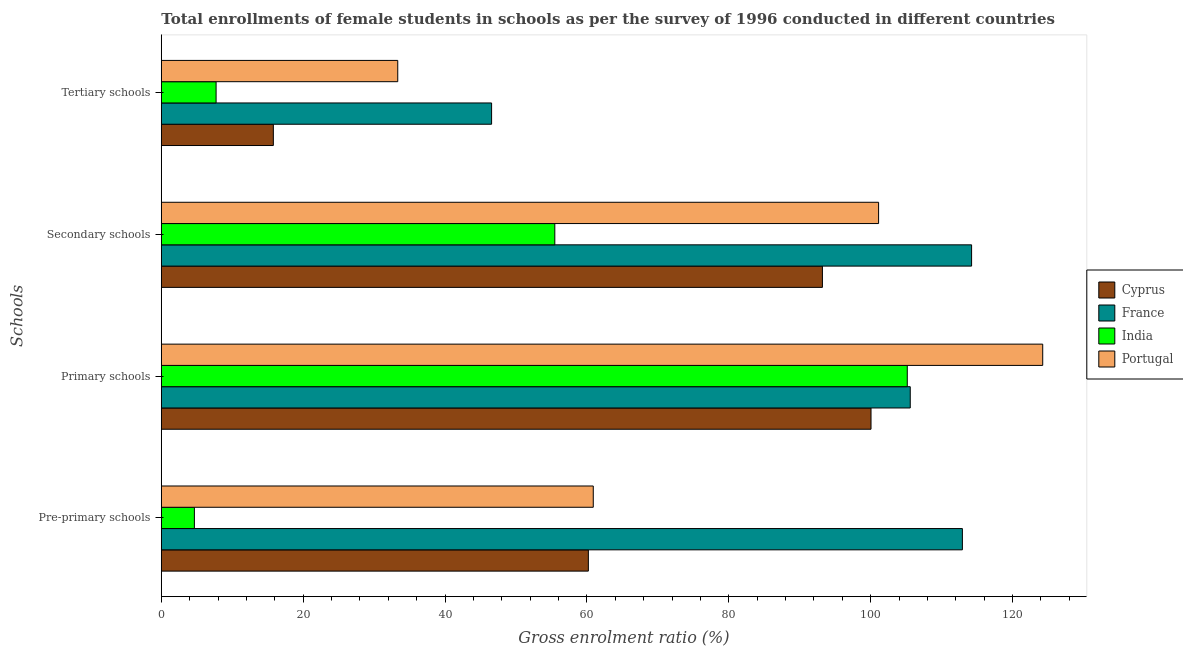How many different coloured bars are there?
Make the answer very short. 4. How many groups of bars are there?
Your answer should be very brief. 4. Are the number of bars on each tick of the Y-axis equal?
Keep it short and to the point. Yes. What is the label of the 1st group of bars from the top?
Offer a terse response. Tertiary schools. What is the gross enrolment ratio(female) in primary schools in Cyprus?
Provide a succinct answer. 100.05. Across all countries, what is the maximum gross enrolment ratio(female) in secondary schools?
Make the answer very short. 114.23. Across all countries, what is the minimum gross enrolment ratio(female) in tertiary schools?
Give a very brief answer. 7.72. What is the total gross enrolment ratio(female) in tertiary schools in the graph?
Your answer should be compact. 103.41. What is the difference between the gross enrolment ratio(female) in pre-primary schools in Cyprus and that in France?
Offer a very short reply. -52.73. What is the difference between the gross enrolment ratio(female) in tertiary schools in Cyprus and the gross enrolment ratio(female) in pre-primary schools in Portugal?
Make the answer very short. -45.1. What is the average gross enrolment ratio(female) in primary schools per country?
Your answer should be compact. 108.76. What is the difference between the gross enrolment ratio(female) in primary schools and gross enrolment ratio(female) in secondary schools in Cyprus?
Your answer should be very brief. 6.85. In how many countries, is the gross enrolment ratio(female) in pre-primary schools greater than 64 %?
Ensure brevity in your answer.  1. What is the ratio of the gross enrolment ratio(female) in pre-primary schools in France to that in India?
Provide a succinct answer. 24.22. What is the difference between the highest and the second highest gross enrolment ratio(female) in tertiary schools?
Ensure brevity in your answer.  13.23. What is the difference between the highest and the lowest gross enrolment ratio(female) in secondary schools?
Give a very brief answer. 58.76. In how many countries, is the gross enrolment ratio(female) in secondary schools greater than the average gross enrolment ratio(female) in secondary schools taken over all countries?
Make the answer very short. 3. Is the sum of the gross enrolment ratio(female) in tertiary schools in Portugal and India greater than the maximum gross enrolment ratio(female) in secondary schools across all countries?
Your response must be concise. No. Is it the case that in every country, the sum of the gross enrolment ratio(female) in primary schools and gross enrolment ratio(female) in secondary schools is greater than the sum of gross enrolment ratio(female) in pre-primary schools and gross enrolment ratio(female) in tertiary schools?
Provide a succinct answer. Yes. What does the 3rd bar from the top in Tertiary schools represents?
Ensure brevity in your answer.  France. What does the 4th bar from the bottom in Tertiary schools represents?
Make the answer very short. Portugal. How many bars are there?
Your answer should be compact. 16. How many countries are there in the graph?
Your response must be concise. 4. What is the difference between two consecutive major ticks on the X-axis?
Offer a terse response. 20. How many legend labels are there?
Your answer should be very brief. 4. What is the title of the graph?
Provide a short and direct response. Total enrollments of female students in schools as per the survey of 1996 conducted in different countries. What is the label or title of the X-axis?
Offer a terse response. Gross enrolment ratio (%). What is the label or title of the Y-axis?
Ensure brevity in your answer.  Schools. What is the Gross enrolment ratio (%) of Cyprus in Pre-primary schools?
Ensure brevity in your answer.  60.2. What is the Gross enrolment ratio (%) of France in Pre-primary schools?
Provide a succinct answer. 112.93. What is the Gross enrolment ratio (%) in India in Pre-primary schools?
Make the answer very short. 4.66. What is the Gross enrolment ratio (%) in Portugal in Pre-primary schools?
Your answer should be compact. 60.9. What is the Gross enrolment ratio (%) of Cyprus in Primary schools?
Your response must be concise. 100.05. What is the Gross enrolment ratio (%) of France in Primary schools?
Your response must be concise. 105.58. What is the Gross enrolment ratio (%) of India in Primary schools?
Your answer should be compact. 105.16. What is the Gross enrolment ratio (%) of Portugal in Primary schools?
Your response must be concise. 124.26. What is the Gross enrolment ratio (%) of Cyprus in Secondary schools?
Offer a terse response. 93.2. What is the Gross enrolment ratio (%) in France in Secondary schools?
Ensure brevity in your answer.  114.23. What is the Gross enrolment ratio (%) of India in Secondary schools?
Provide a succinct answer. 55.47. What is the Gross enrolment ratio (%) in Portugal in Secondary schools?
Offer a terse response. 101.12. What is the Gross enrolment ratio (%) of Cyprus in Tertiary schools?
Your response must be concise. 15.79. What is the Gross enrolment ratio (%) in France in Tertiary schools?
Ensure brevity in your answer.  46.56. What is the Gross enrolment ratio (%) of India in Tertiary schools?
Make the answer very short. 7.72. What is the Gross enrolment ratio (%) in Portugal in Tertiary schools?
Ensure brevity in your answer.  33.33. Across all Schools, what is the maximum Gross enrolment ratio (%) of Cyprus?
Provide a succinct answer. 100.05. Across all Schools, what is the maximum Gross enrolment ratio (%) of France?
Your answer should be compact. 114.23. Across all Schools, what is the maximum Gross enrolment ratio (%) in India?
Your response must be concise. 105.16. Across all Schools, what is the maximum Gross enrolment ratio (%) in Portugal?
Keep it short and to the point. 124.26. Across all Schools, what is the minimum Gross enrolment ratio (%) of Cyprus?
Offer a very short reply. 15.79. Across all Schools, what is the minimum Gross enrolment ratio (%) in France?
Provide a succinct answer. 46.56. Across all Schools, what is the minimum Gross enrolment ratio (%) in India?
Make the answer very short. 4.66. Across all Schools, what is the minimum Gross enrolment ratio (%) in Portugal?
Provide a short and direct response. 33.33. What is the total Gross enrolment ratio (%) of Cyprus in the graph?
Your answer should be compact. 269.25. What is the total Gross enrolment ratio (%) in France in the graph?
Ensure brevity in your answer.  379.3. What is the total Gross enrolment ratio (%) in India in the graph?
Give a very brief answer. 173.02. What is the total Gross enrolment ratio (%) in Portugal in the graph?
Keep it short and to the point. 319.6. What is the difference between the Gross enrolment ratio (%) of Cyprus in Pre-primary schools and that in Primary schools?
Offer a terse response. -39.85. What is the difference between the Gross enrolment ratio (%) of France in Pre-primary schools and that in Primary schools?
Make the answer very short. 7.35. What is the difference between the Gross enrolment ratio (%) in India in Pre-primary schools and that in Primary schools?
Offer a terse response. -100.5. What is the difference between the Gross enrolment ratio (%) in Portugal in Pre-primary schools and that in Primary schools?
Offer a terse response. -63.36. What is the difference between the Gross enrolment ratio (%) of Cyprus in Pre-primary schools and that in Secondary schools?
Offer a very short reply. -33. What is the difference between the Gross enrolment ratio (%) of France in Pre-primary schools and that in Secondary schools?
Offer a terse response. -1.3. What is the difference between the Gross enrolment ratio (%) in India in Pre-primary schools and that in Secondary schools?
Your answer should be compact. -50.81. What is the difference between the Gross enrolment ratio (%) of Portugal in Pre-primary schools and that in Secondary schools?
Your response must be concise. -40.22. What is the difference between the Gross enrolment ratio (%) in Cyprus in Pre-primary schools and that in Tertiary schools?
Offer a terse response. 44.41. What is the difference between the Gross enrolment ratio (%) of France in Pre-primary schools and that in Tertiary schools?
Your answer should be compact. 66.37. What is the difference between the Gross enrolment ratio (%) of India in Pre-primary schools and that in Tertiary schools?
Give a very brief answer. -3.06. What is the difference between the Gross enrolment ratio (%) in Portugal in Pre-primary schools and that in Tertiary schools?
Provide a short and direct response. 27.56. What is the difference between the Gross enrolment ratio (%) in Cyprus in Primary schools and that in Secondary schools?
Give a very brief answer. 6.85. What is the difference between the Gross enrolment ratio (%) in France in Primary schools and that in Secondary schools?
Your response must be concise. -8.65. What is the difference between the Gross enrolment ratio (%) in India in Primary schools and that in Secondary schools?
Your answer should be compact. 49.69. What is the difference between the Gross enrolment ratio (%) in Portugal in Primary schools and that in Secondary schools?
Offer a very short reply. 23.14. What is the difference between the Gross enrolment ratio (%) of Cyprus in Primary schools and that in Tertiary schools?
Your answer should be compact. 84.26. What is the difference between the Gross enrolment ratio (%) in France in Primary schools and that in Tertiary schools?
Your response must be concise. 59.02. What is the difference between the Gross enrolment ratio (%) of India in Primary schools and that in Tertiary schools?
Provide a succinct answer. 97.44. What is the difference between the Gross enrolment ratio (%) in Portugal in Primary schools and that in Tertiary schools?
Offer a terse response. 90.92. What is the difference between the Gross enrolment ratio (%) in Cyprus in Secondary schools and that in Tertiary schools?
Offer a very short reply. 77.41. What is the difference between the Gross enrolment ratio (%) of France in Secondary schools and that in Tertiary schools?
Provide a succinct answer. 67.67. What is the difference between the Gross enrolment ratio (%) in India in Secondary schools and that in Tertiary schools?
Your answer should be very brief. 47.75. What is the difference between the Gross enrolment ratio (%) in Portugal in Secondary schools and that in Tertiary schools?
Provide a short and direct response. 67.79. What is the difference between the Gross enrolment ratio (%) in Cyprus in Pre-primary schools and the Gross enrolment ratio (%) in France in Primary schools?
Offer a terse response. -45.38. What is the difference between the Gross enrolment ratio (%) in Cyprus in Pre-primary schools and the Gross enrolment ratio (%) in India in Primary schools?
Your answer should be compact. -44.96. What is the difference between the Gross enrolment ratio (%) in Cyprus in Pre-primary schools and the Gross enrolment ratio (%) in Portugal in Primary schools?
Provide a short and direct response. -64.05. What is the difference between the Gross enrolment ratio (%) in France in Pre-primary schools and the Gross enrolment ratio (%) in India in Primary schools?
Make the answer very short. 7.77. What is the difference between the Gross enrolment ratio (%) of France in Pre-primary schools and the Gross enrolment ratio (%) of Portugal in Primary schools?
Your response must be concise. -11.32. What is the difference between the Gross enrolment ratio (%) in India in Pre-primary schools and the Gross enrolment ratio (%) in Portugal in Primary schools?
Your answer should be very brief. -119.59. What is the difference between the Gross enrolment ratio (%) of Cyprus in Pre-primary schools and the Gross enrolment ratio (%) of France in Secondary schools?
Offer a very short reply. -54.03. What is the difference between the Gross enrolment ratio (%) of Cyprus in Pre-primary schools and the Gross enrolment ratio (%) of India in Secondary schools?
Make the answer very short. 4.73. What is the difference between the Gross enrolment ratio (%) in Cyprus in Pre-primary schools and the Gross enrolment ratio (%) in Portugal in Secondary schools?
Give a very brief answer. -40.92. What is the difference between the Gross enrolment ratio (%) in France in Pre-primary schools and the Gross enrolment ratio (%) in India in Secondary schools?
Your answer should be very brief. 57.46. What is the difference between the Gross enrolment ratio (%) in France in Pre-primary schools and the Gross enrolment ratio (%) in Portugal in Secondary schools?
Your response must be concise. 11.81. What is the difference between the Gross enrolment ratio (%) in India in Pre-primary schools and the Gross enrolment ratio (%) in Portugal in Secondary schools?
Make the answer very short. -96.46. What is the difference between the Gross enrolment ratio (%) in Cyprus in Pre-primary schools and the Gross enrolment ratio (%) in France in Tertiary schools?
Ensure brevity in your answer.  13.64. What is the difference between the Gross enrolment ratio (%) in Cyprus in Pre-primary schools and the Gross enrolment ratio (%) in India in Tertiary schools?
Offer a terse response. 52.48. What is the difference between the Gross enrolment ratio (%) of Cyprus in Pre-primary schools and the Gross enrolment ratio (%) of Portugal in Tertiary schools?
Ensure brevity in your answer.  26.87. What is the difference between the Gross enrolment ratio (%) in France in Pre-primary schools and the Gross enrolment ratio (%) in India in Tertiary schools?
Provide a short and direct response. 105.21. What is the difference between the Gross enrolment ratio (%) of France in Pre-primary schools and the Gross enrolment ratio (%) of Portugal in Tertiary schools?
Your response must be concise. 79.6. What is the difference between the Gross enrolment ratio (%) of India in Pre-primary schools and the Gross enrolment ratio (%) of Portugal in Tertiary schools?
Ensure brevity in your answer.  -28.67. What is the difference between the Gross enrolment ratio (%) in Cyprus in Primary schools and the Gross enrolment ratio (%) in France in Secondary schools?
Provide a short and direct response. -14.18. What is the difference between the Gross enrolment ratio (%) in Cyprus in Primary schools and the Gross enrolment ratio (%) in India in Secondary schools?
Offer a terse response. 44.58. What is the difference between the Gross enrolment ratio (%) in Cyprus in Primary schools and the Gross enrolment ratio (%) in Portugal in Secondary schools?
Offer a very short reply. -1.07. What is the difference between the Gross enrolment ratio (%) in France in Primary schools and the Gross enrolment ratio (%) in India in Secondary schools?
Your answer should be very brief. 50.11. What is the difference between the Gross enrolment ratio (%) of France in Primary schools and the Gross enrolment ratio (%) of Portugal in Secondary schools?
Provide a succinct answer. 4.46. What is the difference between the Gross enrolment ratio (%) in India in Primary schools and the Gross enrolment ratio (%) in Portugal in Secondary schools?
Provide a short and direct response. 4.04. What is the difference between the Gross enrolment ratio (%) of Cyprus in Primary schools and the Gross enrolment ratio (%) of France in Tertiary schools?
Provide a succinct answer. 53.49. What is the difference between the Gross enrolment ratio (%) of Cyprus in Primary schools and the Gross enrolment ratio (%) of India in Tertiary schools?
Keep it short and to the point. 92.33. What is the difference between the Gross enrolment ratio (%) of Cyprus in Primary schools and the Gross enrolment ratio (%) of Portugal in Tertiary schools?
Provide a short and direct response. 66.72. What is the difference between the Gross enrolment ratio (%) of France in Primary schools and the Gross enrolment ratio (%) of India in Tertiary schools?
Your answer should be compact. 97.86. What is the difference between the Gross enrolment ratio (%) of France in Primary schools and the Gross enrolment ratio (%) of Portugal in Tertiary schools?
Offer a very short reply. 72.25. What is the difference between the Gross enrolment ratio (%) of India in Primary schools and the Gross enrolment ratio (%) of Portugal in Tertiary schools?
Offer a very short reply. 71.83. What is the difference between the Gross enrolment ratio (%) of Cyprus in Secondary schools and the Gross enrolment ratio (%) of France in Tertiary schools?
Provide a succinct answer. 46.64. What is the difference between the Gross enrolment ratio (%) of Cyprus in Secondary schools and the Gross enrolment ratio (%) of India in Tertiary schools?
Make the answer very short. 85.48. What is the difference between the Gross enrolment ratio (%) in Cyprus in Secondary schools and the Gross enrolment ratio (%) in Portugal in Tertiary schools?
Keep it short and to the point. 59.87. What is the difference between the Gross enrolment ratio (%) in France in Secondary schools and the Gross enrolment ratio (%) in India in Tertiary schools?
Provide a short and direct response. 106.51. What is the difference between the Gross enrolment ratio (%) of France in Secondary schools and the Gross enrolment ratio (%) of Portugal in Tertiary schools?
Your answer should be compact. 80.9. What is the difference between the Gross enrolment ratio (%) in India in Secondary schools and the Gross enrolment ratio (%) in Portugal in Tertiary schools?
Provide a succinct answer. 22.14. What is the average Gross enrolment ratio (%) of Cyprus per Schools?
Your answer should be compact. 67.31. What is the average Gross enrolment ratio (%) in France per Schools?
Offer a very short reply. 94.83. What is the average Gross enrolment ratio (%) in India per Schools?
Provide a short and direct response. 43.26. What is the average Gross enrolment ratio (%) of Portugal per Schools?
Offer a very short reply. 79.9. What is the difference between the Gross enrolment ratio (%) of Cyprus and Gross enrolment ratio (%) of France in Pre-primary schools?
Your answer should be very brief. -52.73. What is the difference between the Gross enrolment ratio (%) in Cyprus and Gross enrolment ratio (%) in India in Pre-primary schools?
Make the answer very short. 55.54. What is the difference between the Gross enrolment ratio (%) of Cyprus and Gross enrolment ratio (%) of Portugal in Pre-primary schools?
Your answer should be very brief. -0.69. What is the difference between the Gross enrolment ratio (%) of France and Gross enrolment ratio (%) of India in Pre-primary schools?
Ensure brevity in your answer.  108.27. What is the difference between the Gross enrolment ratio (%) of France and Gross enrolment ratio (%) of Portugal in Pre-primary schools?
Ensure brevity in your answer.  52.04. What is the difference between the Gross enrolment ratio (%) of India and Gross enrolment ratio (%) of Portugal in Pre-primary schools?
Provide a short and direct response. -56.23. What is the difference between the Gross enrolment ratio (%) of Cyprus and Gross enrolment ratio (%) of France in Primary schools?
Offer a terse response. -5.53. What is the difference between the Gross enrolment ratio (%) of Cyprus and Gross enrolment ratio (%) of India in Primary schools?
Your answer should be compact. -5.11. What is the difference between the Gross enrolment ratio (%) of Cyprus and Gross enrolment ratio (%) of Portugal in Primary schools?
Give a very brief answer. -24.21. What is the difference between the Gross enrolment ratio (%) in France and Gross enrolment ratio (%) in India in Primary schools?
Keep it short and to the point. 0.42. What is the difference between the Gross enrolment ratio (%) in France and Gross enrolment ratio (%) in Portugal in Primary schools?
Ensure brevity in your answer.  -18.67. What is the difference between the Gross enrolment ratio (%) of India and Gross enrolment ratio (%) of Portugal in Primary schools?
Your response must be concise. -19.09. What is the difference between the Gross enrolment ratio (%) of Cyprus and Gross enrolment ratio (%) of France in Secondary schools?
Offer a very short reply. -21.03. What is the difference between the Gross enrolment ratio (%) of Cyprus and Gross enrolment ratio (%) of India in Secondary schools?
Offer a very short reply. 37.73. What is the difference between the Gross enrolment ratio (%) in Cyprus and Gross enrolment ratio (%) in Portugal in Secondary schools?
Provide a short and direct response. -7.92. What is the difference between the Gross enrolment ratio (%) of France and Gross enrolment ratio (%) of India in Secondary schools?
Ensure brevity in your answer.  58.76. What is the difference between the Gross enrolment ratio (%) of France and Gross enrolment ratio (%) of Portugal in Secondary schools?
Offer a very short reply. 13.11. What is the difference between the Gross enrolment ratio (%) of India and Gross enrolment ratio (%) of Portugal in Secondary schools?
Offer a very short reply. -45.65. What is the difference between the Gross enrolment ratio (%) of Cyprus and Gross enrolment ratio (%) of France in Tertiary schools?
Give a very brief answer. -30.77. What is the difference between the Gross enrolment ratio (%) of Cyprus and Gross enrolment ratio (%) of India in Tertiary schools?
Give a very brief answer. 8.07. What is the difference between the Gross enrolment ratio (%) in Cyprus and Gross enrolment ratio (%) in Portugal in Tertiary schools?
Offer a terse response. -17.54. What is the difference between the Gross enrolment ratio (%) of France and Gross enrolment ratio (%) of India in Tertiary schools?
Your answer should be very brief. 38.84. What is the difference between the Gross enrolment ratio (%) of France and Gross enrolment ratio (%) of Portugal in Tertiary schools?
Ensure brevity in your answer.  13.23. What is the difference between the Gross enrolment ratio (%) in India and Gross enrolment ratio (%) in Portugal in Tertiary schools?
Offer a terse response. -25.61. What is the ratio of the Gross enrolment ratio (%) in Cyprus in Pre-primary schools to that in Primary schools?
Offer a very short reply. 0.6. What is the ratio of the Gross enrolment ratio (%) of France in Pre-primary schools to that in Primary schools?
Your answer should be compact. 1.07. What is the ratio of the Gross enrolment ratio (%) in India in Pre-primary schools to that in Primary schools?
Offer a terse response. 0.04. What is the ratio of the Gross enrolment ratio (%) of Portugal in Pre-primary schools to that in Primary schools?
Keep it short and to the point. 0.49. What is the ratio of the Gross enrolment ratio (%) in Cyprus in Pre-primary schools to that in Secondary schools?
Give a very brief answer. 0.65. What is the ratio of the Gross enrolment ratio (%) of France in Pre-primary schools to that in Secondary schools?
Ensure brevity in your answer.  0.99. What is the ratio of the Gross enrolment ratio (%) in India in Pre-primary schools to that in Secondary schools?
Provide a succinct answer. 0.08. What is the ratio of the Gross enrolment ratio (%) in Portugal in Pre-primary schools to that in Secondary schools?
Your response must be concise. 0.6. What is the ratio of the Gross enrolment ratio (%) of Cyprus in Pre-primary schools to that in Tertiary schools?
Make the answer very short. 3.81. What is the ratio of the Gross enrolment ratio (%) in France in Pre-primary schools to that in Tertiary schools?
Offer a terse response. 2.43. What is the ratio of the Gross enrolment ratio (%) of India in Pre-primary schools to that in Tertiary schools?
Provide a short and direct response. 0.6. What is the ratio of the Gross enrolment ratio (%) in Portugal in Pre-primary schools to that in Tertiary schools?
Your response must be concise. 1.83. What is the ratio of the Gross enrolment ratio (%) in Cyprus in Primary schools to that in Secondary schools?
Offer a very short reply. 1.07. What is the ratio of the Gross enrolment ratio (%) in France in Primary schools to that in Secondary schools?
Offer a terse response. 0.92. What is the ratio of the Gross enrolment ratio (%) in India in Primary schools to that in Secondary schools?
Your answer should be compact. 1.9. What is the ratio of the Gross enrolment ratio (%) in Portugal in Primary schools to that in Secondary schools?
Provide a succinct answer. 1.23. What is the ratio of the Gross enrolment ratio (%) in Cyprus in Primary schools to that in Tertiary schools?
Offer a terse response. 6.33. What is the ratio of the Gross enrolment ratio (%) in France in Primary schools to that in Tertiary schools?
Provide a succinct answer. 2.27. What is the ratio of the Gross enrolment ratio (%) in India in Primary schools to that in Tertiary schools?
Offer a terse response. 13.62. What is the ratio of the Gross enrolment ratio (%) of Portugal in Primary schools to that in Tertiary schools?
Keep it short and to the point. 3.73. What is the ratio of the Gross enrolment ratio (%) of Cyprus in Secondary schools to that in Tertiary schools?
Give a very brief answer. 5.9. What is the ratio of the Gross enrolment ratio (%) in France in Secondary schools to that in Tertiary schools?
Your answer should be very brief. 2.45. What is the ratio of the Gross enrolment ratio (%) of India in Secondary schools to that in Tertiary schools?
Ensure brevity in your answer.  7.18. What is the ratio of the Gross enrolment ratio (%) of Portugal in Secondary schools to that in Tertiary schools?
Keep it short and to the point. 3.03. What is the difference between the highest and the second highest Gross enrolment ratio (%) of Cyprus?
Your answer should be very brief. 6.85. What is the difference between the highest and the second highest Gross enrolment ratio (%) of France?
Your response must be concise. 1.3. What is the difference between the highest and the second highest Gross enrolment ratio (%) in India?
Your answer should be very brief. 49.69. What is the difference between the highest and the second highest Gross enrolment ratio (%) of Portugal?
Your answer should be compact. 23.14. What is the difference between the highest and the lowest Gross enrolment ratio (%) in Cyprus?
Provide a short and direct response. 84.26. What is the difference between the highest and the lowest Gross enrolment ratio (%) in France?
Your answer should be compact. 67.67. What is the difference between the highest and the lowest Gross enrolment ratio (%) of India?
Offer a terse response. 100.5. What is the difference between the highest and the lowest Gross enrolment ratio (%) in Portugal?
Provide a short and direct response. 90.92. 